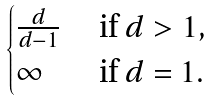Convert formula to latex. <formula><loc_0><loc_0><loc_500><loc_500>\begin{cases} \frac { d } { d - 1 } & \text { if } d > 1 , \\ \infty & \text { if } d = 1 . \end{cases}</formula> 